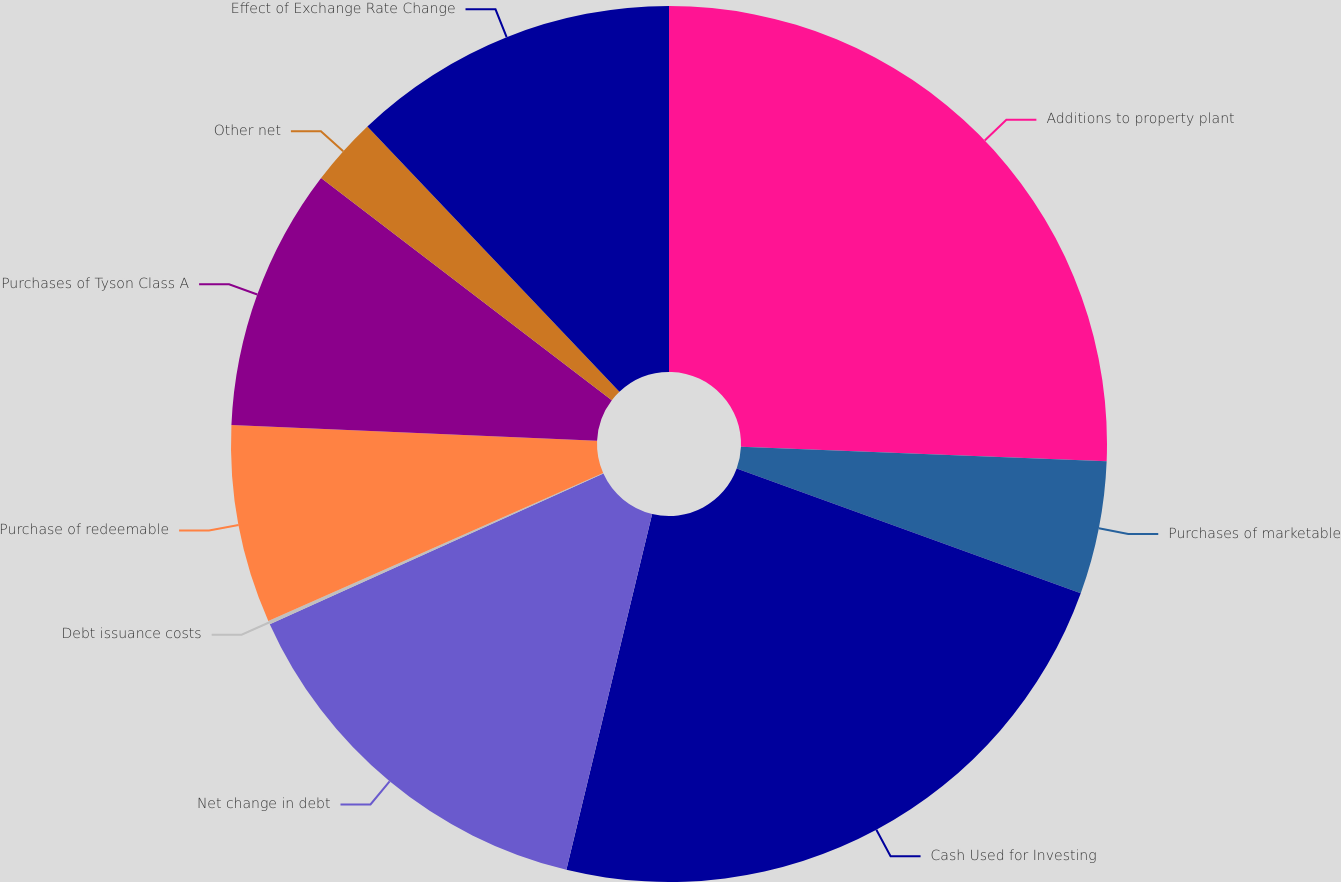<chart> <loc_0><loc_0><loc_500><loc_500><pie_chart><fcel>Additions to property plant<fcel>Purchases of marketable<fcel>Cash Used for Investing<fcel>Net change in debt<fcel>Debt issuance costs<fcel>Purchase of redeemable<fcel>Purchases of Tyson Class A<fcel>Other net<fcel>Effect of Exchange Rate Change<nl><fcel>25.63%<fcel>4.91%<fcel>23.23%<fcel>14.49%<fcel>0.13%<fcel>7.31%<fcel>9.7%<fcel>2.52%<fcel>12.09%<nl></chart> 